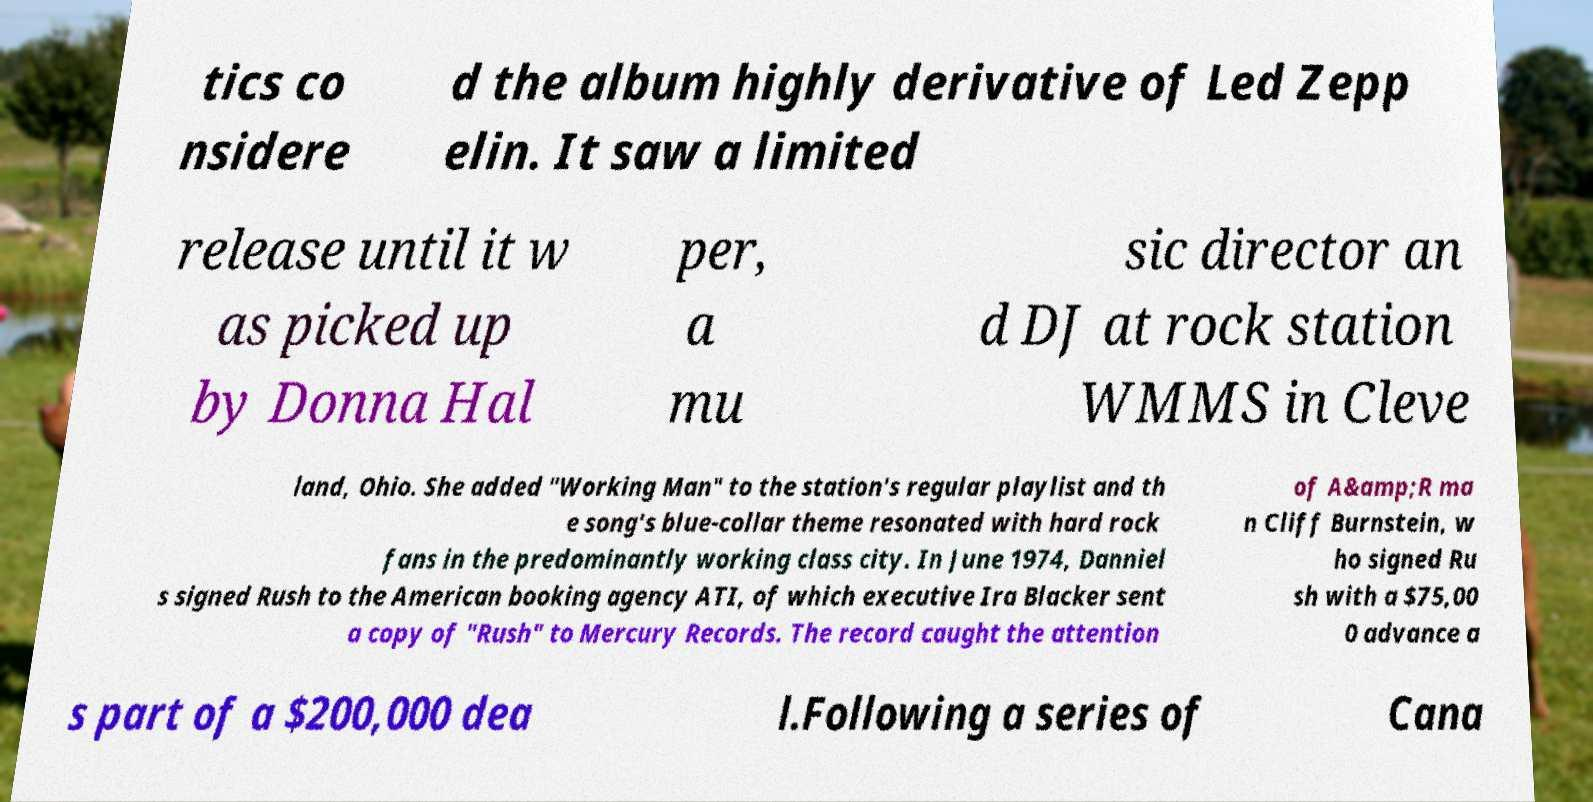Could you extract and type out the text from this image? tics co nsidere d the album highly derivative of Led Zepp elin. It saw a limited release until it w as picked up by Donna Hal per, a mu sic director an d DJ at rock station WMMS in Cleve land, Ohio. She added "Working Man" to the station's regular playlist and th e song's blue-collar theme resonated with hard rock fans in the predominantly working class city. In June 1974, Danniel s signed Rush to the American booking agency ATI, of which executive Ira Blacker sent a copy of "Rush" to Mercury Records. The record caught the attention of A&amp;R ma n Cliff Burnstein, w ho signed Ru sh with a $75,00 0 advance a s part of a $200,000 dea l.Following a series of Cana 